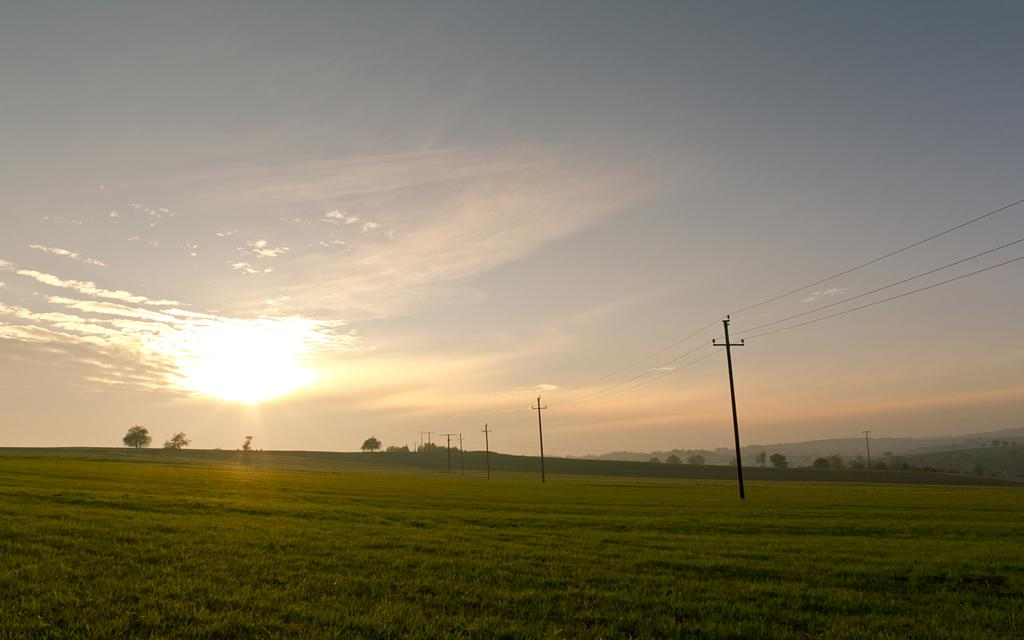What type of vegetation is present in the image? There is grass in the image. What structures can be seen on the ground in the image? There are poles on the ground in the image. What can be seen in the background of the image? There are trees, mountains, and the sky visible in the background of the image. What type of pet is interacting with the group in the image? There is no group or pet present in the image. 